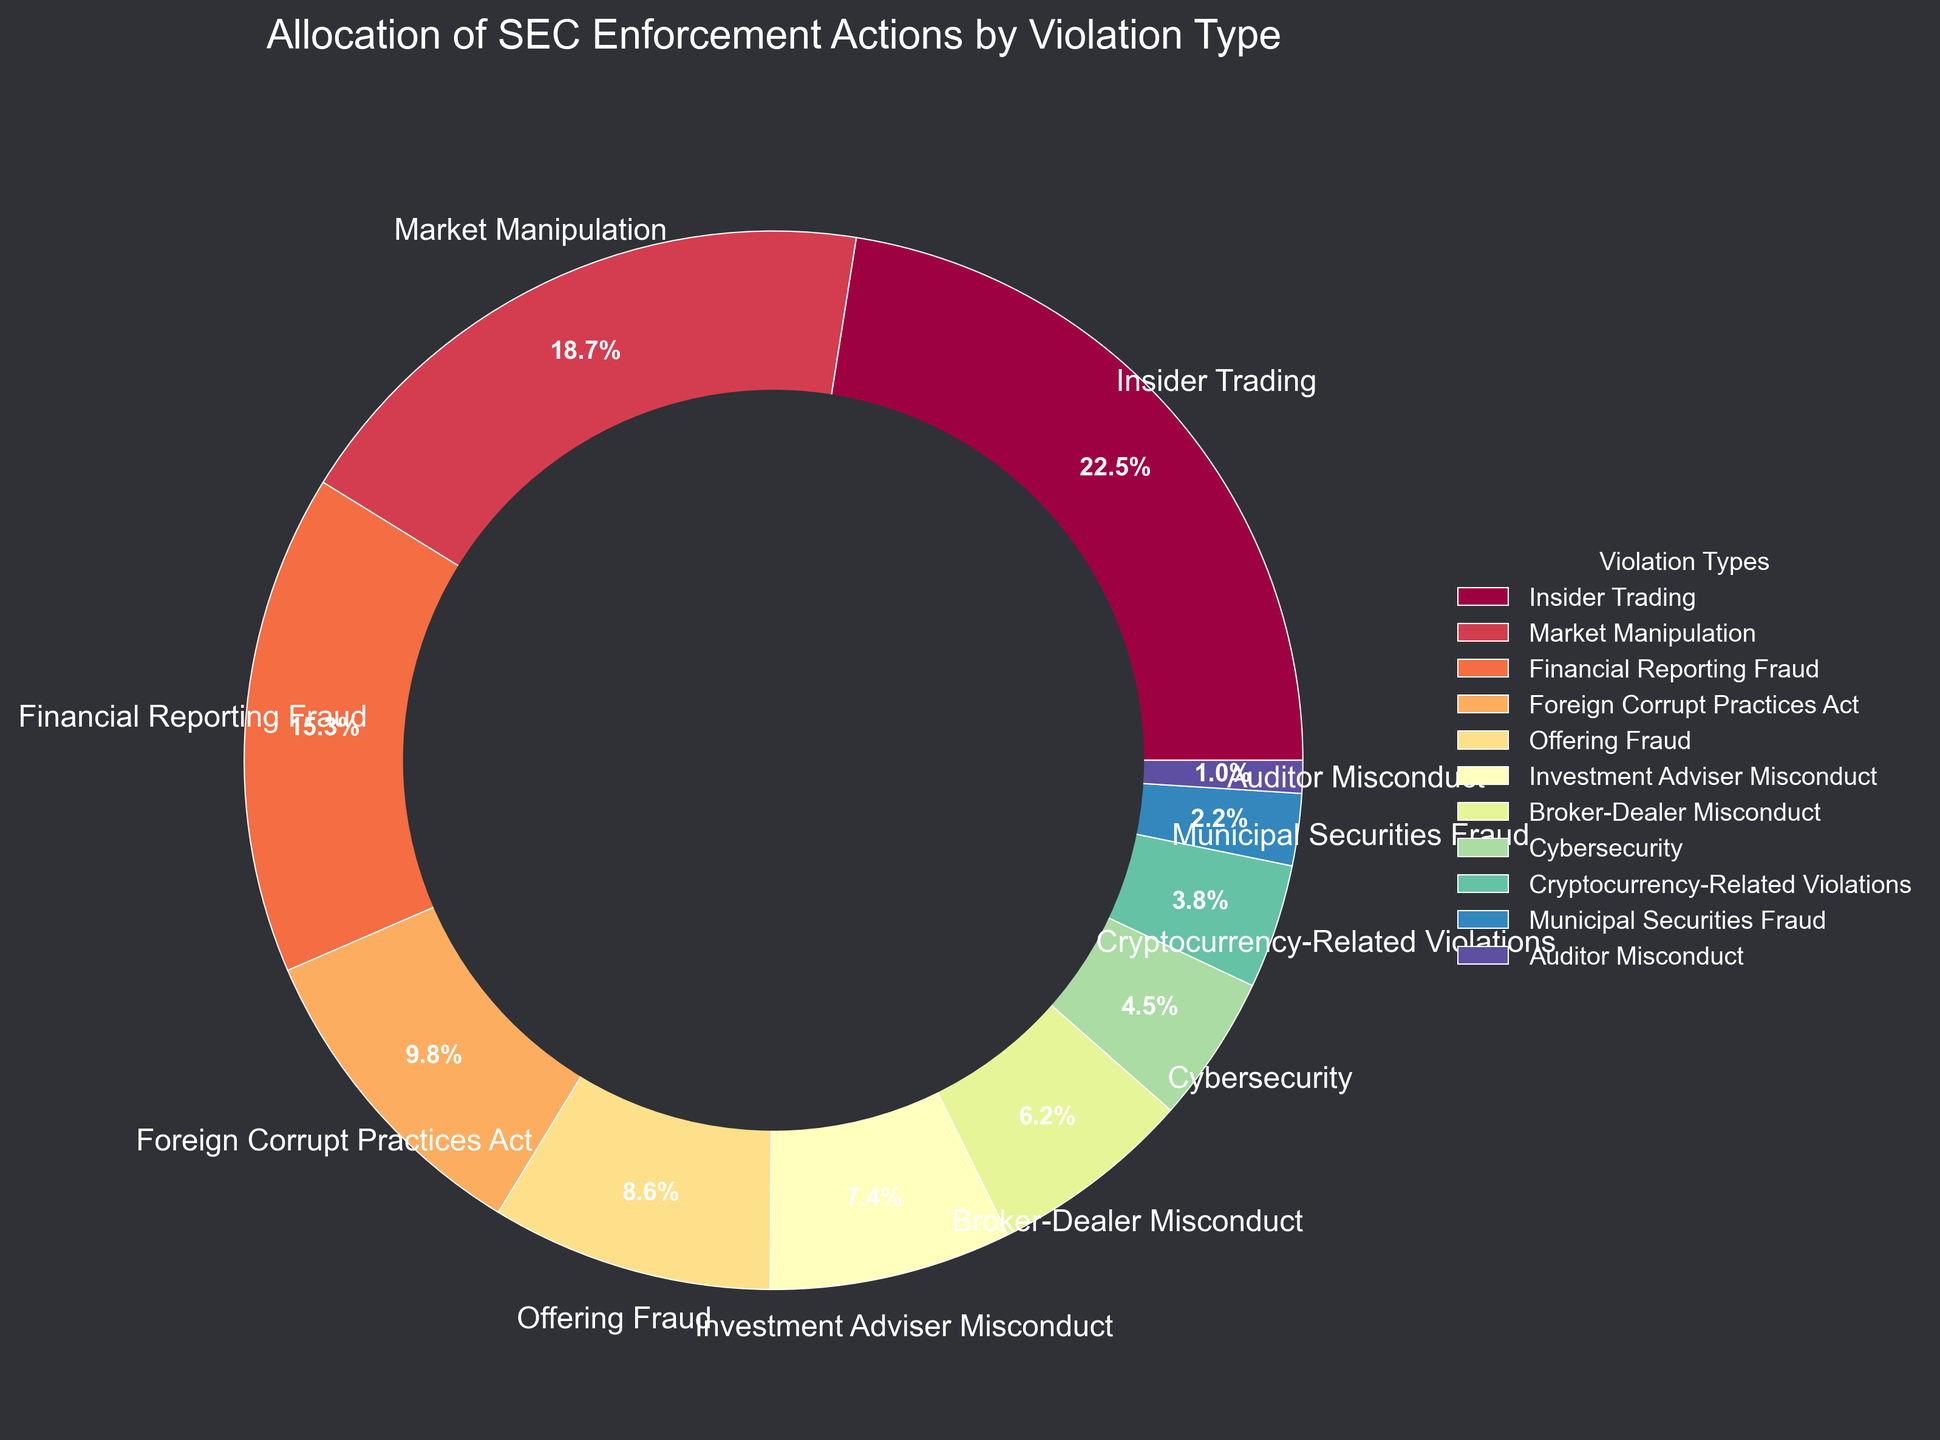Which violation type accounts for the highest percentage of SEC enforcement actions? The chart shows different violation types and their corresponding percentages. By inspecting the segments, "Insider Trading" has the largest portion at 22.5%.
Answer: Insider Trading What is the combined percentage of SEC enforcement actions for Financial Reporting Fraud and Offering Fraud? The percentages for Financial Reporting Fraud and Offering Fraud are 15.3% and 8.6%, respectively. Combining these gives 15.3% + 8.6% = 23.9%.
Answer: 23.9% Which two violation types have the smallest percentages of SEC enforcement actions, and what are their values? By looking at the pie chart's smallest segments, Auditor Misconduct (1.0%) and Municipal Securities Fraud (2.2%) have the smallest percentages.
Answer: Auditor Misconduct and Municipal Securities Fraud; 1.0% and 2.2% Is the percentage of cybersecurity-related violations greater than that of cryptocurrency-related violations? The chart shows Cybersecurity at 4.5% and Cryptocurrency-Related Violations at 3.8%. Comparing the two, 4.5% is greater than 3.8%.
Answer: Yes Compare the sum of percentages for Market Manipulation, Insider Trading, and Cybersecurity. Is it greater than 40%? Summing Market Manipulation, Insider Trading, and Cybersecurity gives 18.7% + 22.5% + 4.5% = 45.7%. This is more than 40%.
Answer: Yes, 45.7% What is the percentage difference between Investment Adviser Misconduct and Broker-Dealer Misconduct? The percentages are 7.4% for Investment Adviser Misconduct and 6.2% for Broker-Dealer Misconduct. The difference is 7.4% - 6.2% = 1.2%.
Answer: 1.2% Considering only Financial Reporting Fraud, Foreign Corrupt Practices Act, and Offering Fraud, what is their average percentage? The percentages are 15.3%, 9.8%, and 8.6% respectively. The total is 33.7%. The average is 33.7% / 3 = 11.23%.
Answer: 11.23% Which visual attribute signifies the Legend in this pie chart? The pie chart includes a color-coded legend positioned outside the chart, explaining the violation types and their corresponding segments.
Answer: Color-coded legend Does the sum of Cybersecurity and Cryptocurrency-Related Violations exceed the percentage of Market Manipulation alone? The percentages are 4.5% for Cybersecurity and 3.8% for Cryptocurrency-Related Violations. Summing them gives 4.5% + 3.8% = 8.3%, which is less than Market Manipulation at 18.7%.
Answer: No 